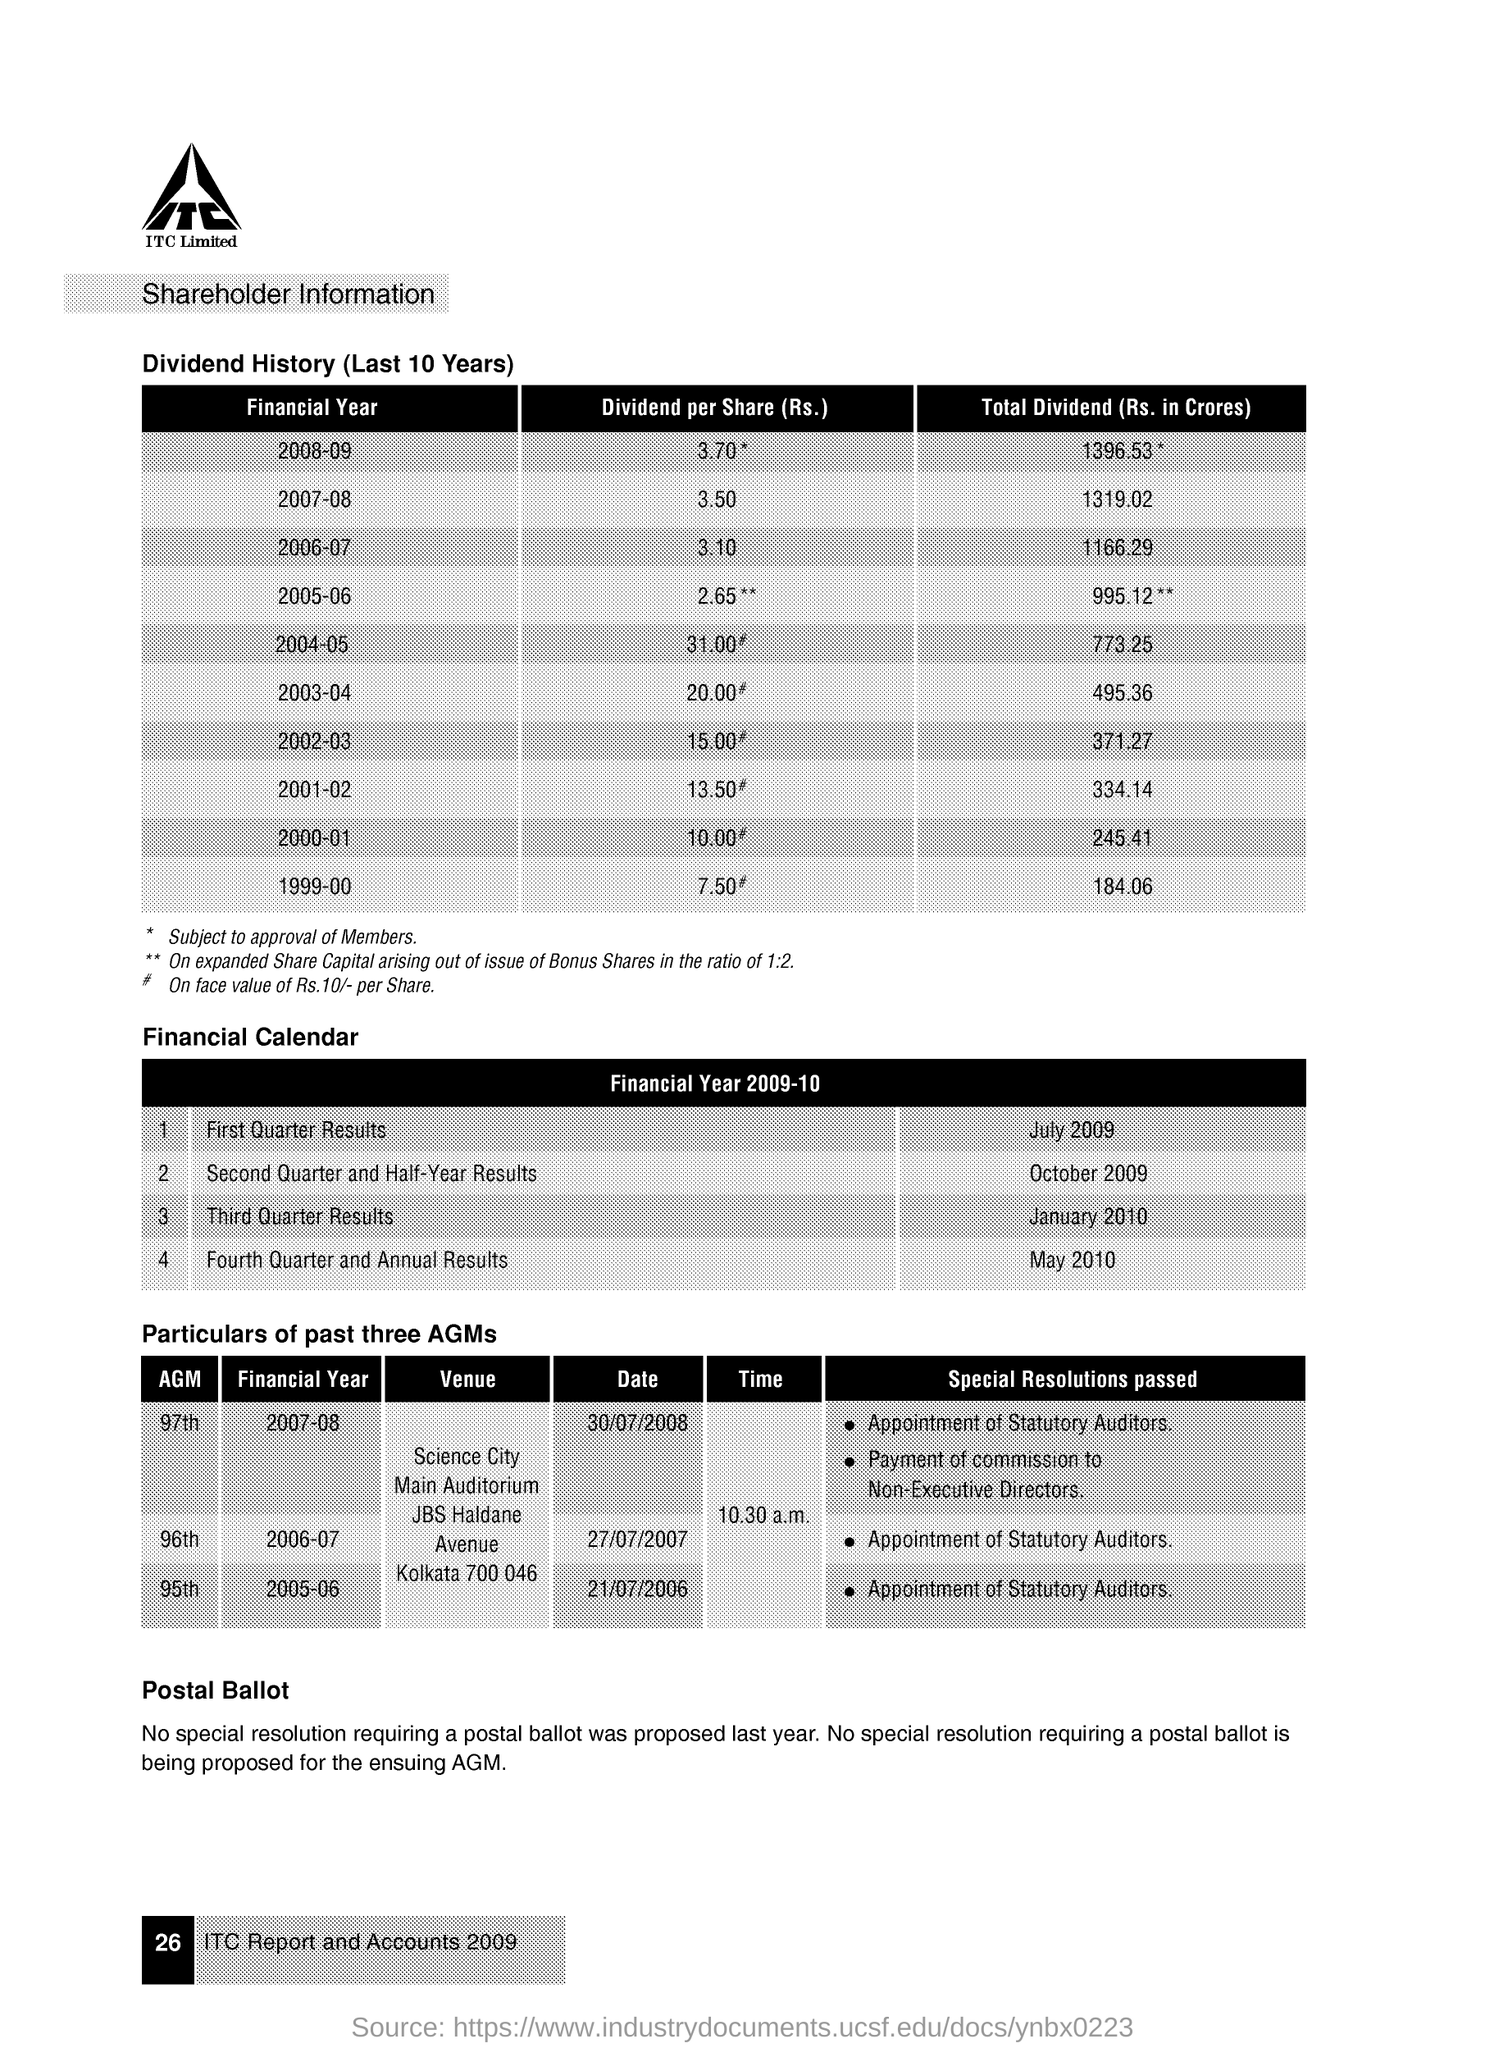What is the value of dividend per share (rs.)for the financial year 2007-08 ?
Give a very brief answer. 3.50. What is the value of dividend per share for the financial year 2006-07 ?
Your answer should be compact. 3.10. When was the first quarter results were announced in  the financial year 2009-10 ?
Your answer should be very brief. JULY 2009. When was the third quarter results were announced in the financial year 2009-10 ?
Your answer should be compact. JANUARY 2010. In which financial year the 97th agm was conducted ?
Provide a succinct answer. 2007-08. What were the special resolutions passes in the 95th agm which was conducted during the financial year 2005-06 ?
Your answer should be compact. APPOINTMENT OF STATUTORY AUDITORS. On which date the 96th agm was conducted ?
Make the answer very short. 27/07/2007. 